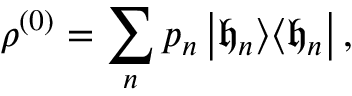<formula> <loc_0><loc_0><loc_500><loc_500>\rho ^ { ( 0 ) } = \sum _ { n } p _ { n } \left | \mathfrak { h } _ { n } \right > \, \left < \mathfrak { h } _ { n } \right | ,</formula> 